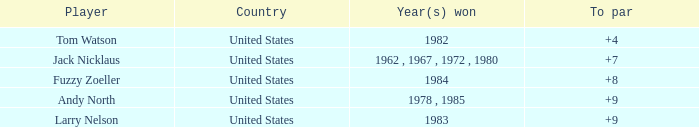Where is andy north's to par over 8 country located? United States. 